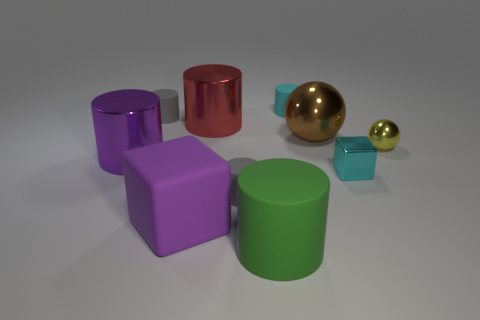Does the cylinder to the right of the large green object have the same color as the block on the right side of the red cylinder?
Your response must be concise. Yes. What number of other objects are the same color as the matte cube?
Your response must be concise. 1. What size is the shiny thing that is to the left of the tiny cyan cylinder and on the right side of the large rubber cube?
Your answer should be compact. Large. The cyan thing that is the same size as the cyan matte cylinder is what shape?
Your answer should be very brief. Cube. Does the large metal cylinder in front of the big brown metallic object have the same color as the matte block?
Your answer should be compact. Yes. There is a cylinder that is the same color as the shiny cube; what is its material?
Your answer should be very brief. Rubber. What shape is the object that is behind the gray object that is behind the ball that is left of the small yellow shiny object?
Offer a very short reply. Cylinder. Do the gray cylinder that is behind the cyan cube and the tiny cyan thing that is right of the small cyan cylinder have the same material?
Your answer should be compact. No. What material is the small cyan object that is the same shape as the green object?
Provide a short and direct response. Rubber. There is a tiny gray thing that is in front of the large purple metal object; does it have the same shape as the big rubber object that is right of the large red cylinder?
Provide a short and direct response. Yes. 